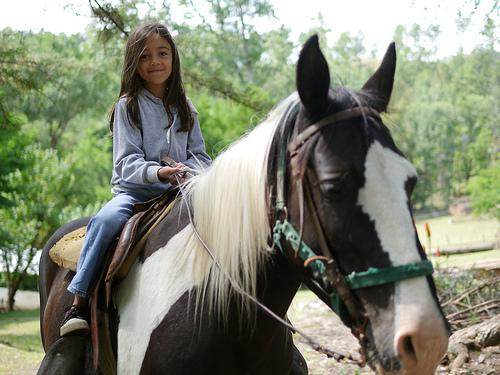Question: how many horses are there?
Choices:
A. Only one.
B. Two.
C. Three.
D. Four.
Answer with the letter. Answer: A Question: who has long hair?
Choices:
A. Girl on horse.
B. Woman watching.
C. Man with newspaper.
D. Old man on bench.
Answer with the letter. Answer: A Question: where was the photo taken?
Choices:
A. At a farm.
B. At the zoo.
C. At the orchard.
D. At a horse ranch.
Answer with the letter. Answer: D Question: what is brown and white?
Choices:
A. Cow.
B. Dog.
C. Horse.
D. Cat.
Answer with the letter. Answer: C Question: what is green?
Choices:
A. Grass.
B. Trees.
C. Automobile.
D. Motorcycle.
Answer with the letter. Answer: B Question: who is riding a horse?
Choices:
A. Young man.
B. Old man.
C. A girl.
D. Jockey.
Answer with the letter. Answer: C 